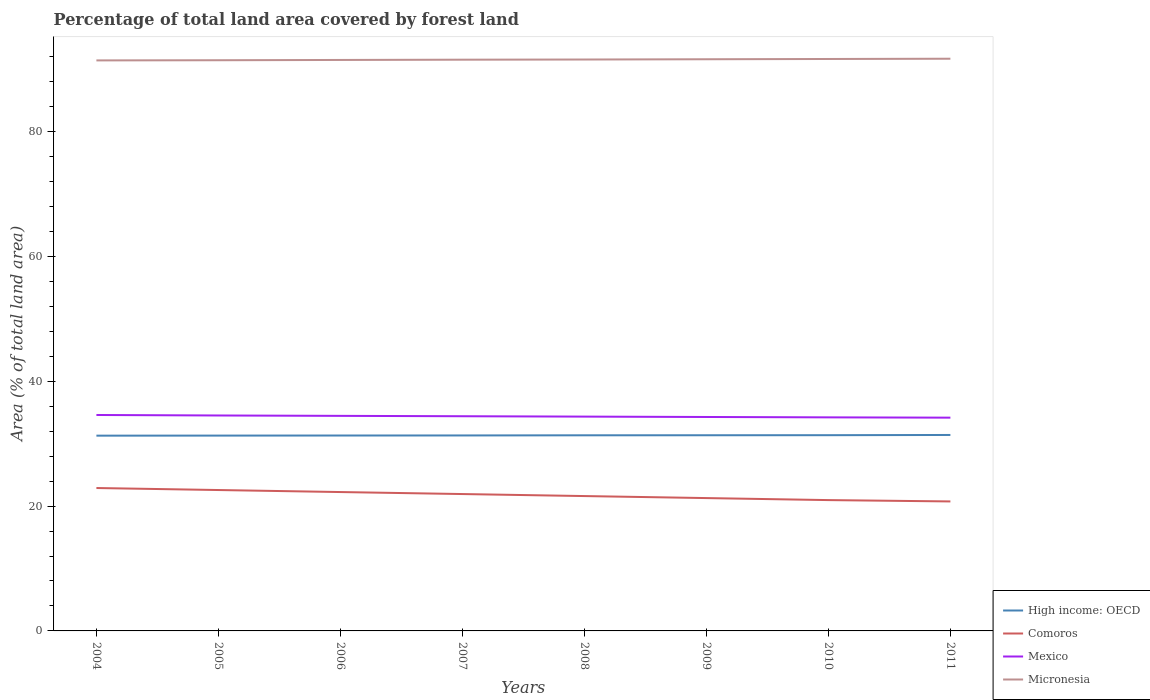How many different coloured lines are there?
Give a very brief answer. 4. Does the line corresponding to Comoros intersect with the line corresponding to Micronesia?
Offer a very short reply. No. Is the number of lines equal to the number of legend labels?
Give a very brief answer. Yes. Across all years, what is the maximum percentage of forest land in High income: OECD?
Offer a very short reply. 31.28. What is the total percentage of forest land in High income: OECD in the graph?
Your answer should be compact. -0.02. What is the difference between the highest and the second highest percentage of forest land in Comoros?
Provide a short and direct response. 2.15. What is the difference between the highest and the lowest percentage of forest land in Comoros?
Make the answer very short. 4. Is the percentage of forest land in Micronesia strictly greater than the percentage of forest land in High income: OECD over the years?
Your answer should be compact. No. How many lines are there?
Keep it short and to the point. 4. Are the values on the major ticks of Y-axis written in scientific E-notation?
Keep it short and to the point. No. Does the graph contain any zero values?
Your answer should be very brief. No. Does the graph contain grids?
Your answer should be compact. No. What is the title of the graph?
Your answer should be compact. Percentage of total land area covered by forest land. What is the label or title of the Y-axis?
Offer a very short reply. Area (% of total land area). What is the Area (% of total land area) of High income: OECD in 2004?
Offer a terse response. 31.28. What is the Area (% of total land area) in Comoros in 2004?
Provide a short and direct response. 22.89. What is the Area (% of total land area) of Mexico in 2004?
Make the answer very short. 34.59. What is the Area (% of total land area) of Micronesia in 2004?
Provide a short and direct response. 91.39. What is the Area (% of total land area) of High income: OECD in 2005?
Offer a very short reply. 31.29. What is the Area (% of total land area) in Comoros in 2005?
Provide a succinct answer. 22.57. What is the Area (% of total land area) of Mexico in 2005?
Offer a very short reply. 34.51. What is the Area (% of total land area) of Micronesia in 2005?
Provide a succinct answer. 91.41. What is the Area (% of total land area) in High income: OECD in 2006?
Keep it short and to the point. 31.3. What is the Area (% of total land area) in Comoros in 2006?
Ensure brevity in your answer.  22.25. What is the Area (% of total land area) in Mexico in 2006?
Offer a terse response. 34.45. What is the Area (% of total land area) in Micronesia in 2006?
Offer a terse response. 91.46. What is the Area (% of total land area) in High income: OECD in 2007?
Keep it short and to the point. 31.31. What is the Area (% of total land area) of Comoros in 2007?
Give a very brief answer. 21.92. What is the Area (% of total land area) in Mexico in 2007?
Offer a very short reply. 34.39. What is the Area (% of total land area) of Micronesia in 2007?
Give a very brief answer. 91.5. What is the Area (% of total land area) in High income: OECD in 2008?
Give a very brief answer. 31.33. What is the Area (% of total land area) in Comoros in 2008?
Offer a terse response. 21.6. What is the Area (% of total land area) of Mexico in 2008?
Offer a terse response. 34.33. What is the Area (% of total land area) in Micronesia in 2008?
Your answer should be compact. 91.53. What is the Area (% of total land area) of High income: OECD in 2009?
Your response must be concise. 31.34. What is the Area (% of total land area) in Comoros in 2009?
Make the answer very short. 21.28. What is the Area (% of total land area) of Mexico in 2009?
Ensure brevity in your answer.  34.27. What is the Area (% of total land area) in Micronesia in 2009?
Your answer should be compact. 91.57. What is the Area (% of total land area) of High income: OECD in 2010?
Make the answer very short. 31.35. What is the Area (% of total land area) of Comoros in 2010?
Provide a succinct answer. 20.96. What is the Area (% of total land area) of Mexico in 2010?
Your response must be concise. 34.21. What is the Area (% of total land area) in Micronesia in 2010?
Offer a very short reply. 91.61. What is the Area (% of total land area) in High income: OECD in 2011?
Ensure brevity in your answer.  31.39. What is the Area (% of total land area) in Comoros in 2011?
Your answer should be very brief. 20.74. What is the Area (% of total land area) of Mexico in 2011?
Make the answer very short. 34.16. What is the Area (% of total land area) in Micronesia in 2011?
Provide a succinct answer. 91.66. Across all years, what is the maximum Area (% of total land area) of High income: OECD?
Provide a short and direct response. 31.39. Across all years, what is the maximum Area (% of total land area) of Comoros?
Provide a short and direct response. 22.89. Across all years, what is the maximum Area (% of total land area) in Mexico?
Offer a terse response. 34.59. Across all years, what is the maximum Area (% of total land area) in Micronesia?
Provide a short and direct response. 91.66. Across all years, what is the minimum Area (% of total land area) in High income: OECD?
Your response must be concise. 31.28. Across all years, what is the minimum Area (% of total land area) of Comoros?
Ensure brevity in your answer.  20.74. Across all years, what is the minimum Area (% of total land area) in Mexico?
Provide a succinct answer. 34.16. Across all years, what is the minimum Area (% of total land area) in Micronesia?
Give a very brief answer. 91.39. What is the total Area (% of total land area) of High income: OECD in the graph?
Your answer should be compact. 250.6. What is the total Area (% of total land area) of Comoros in the graph?
Keep it short and to the point. 174.21. What is the total Area (% of total land area) of Mexico in the graph?
Your answer should be compact. 274.9. What is the total Area (% of total land area) of Micronesia in the graph?
Offer a terse response. 732.13. What is the difference between the Area (% of total land area) in High income: OECD in 2004 and that in 2005?
Ensure brevity in your answer.  -0.01. What is the difference between the Area (% of total land area) in Comoros in 2004 and that in 2005?
Ensure brevity in your answer.  0.32. What is the difference between the Area (% of total land area) of Mexico in 2004 and that in 2005?
Provide a short and direct response. 0.08. What is the difference between the Area (% of total land area) in Micronesia in 2004 and that in 2005?
Provide a succinct answer. -0.03. What is the difference between the Area (% of total land area) in High income: OECD in 2004 and that in 2006?
Your answer should be very brief. -0.02. What is the difference between the Area (% of total land area) of Comoros in 2004 and that in 2006?
Give a very brief answer. 0.64. What is the difference between the Area (% of total land area) in Mexico in 2004 and that in 2006?
Offer a very short reply. 0.14. What is the difference between the Area (% of total land area) in Micronesia in 2004 and that in 2006?
Provide a succinct answer. -0.07. What is the difference between the Area (% of total land area) in High income: OECD in 2004 and that in 2007?
Make the answer very short. -0.03. What is the difference between the Area (% of total land area) of Comoros in 2004 and that in 2007?
Your response must be concise. 0.97. What is the difference between the Area (% of total land area) of Mexico in 2004 and that in 2007?
Your answer should be compact. 0.2. What is the difference between the Area (% of total land area) of Micronesia in 2004 and that in 2007?
Ensure brevity in your answer.  -0.11. What is the difference between the Area (% of total land area) of High income: OECD in 2004 and that in 2008?
Your answer should be very brief. -0.06. What is the difference between the Area (% of total land area) in Comoros in 2004 and that in 2008?
Provide a succinct answer. 1.29. What is the difference between the Area (% of total land area) of Mexico in 2004 and that in 2008?
Offer a very short reply. 0.26. What is the difference between the Area (% of total land area) of Micronesia in 2004 and that in 2008?
Your answer should be very brief. -0.14. What is the difference between the Area (% of total land area) in High income: OECD in 2004 and that in 2009?
Your answer should be very brief. -0.07. What is the difference between the Area (% of total land area) in Comoros in 2004 and that in 2009?
Offer a terse response. 1.61. What is the difference between the Area (% of total land area) of Mexico in 2004 and that in 2009?
Give a very brief answer. 0.32. What is the difference between the Area (% of total land area) of Micronesia in 2004 and that in 2009?
Your response must be concise. -0.19. What is the difference between the Area (% of total land area) in High income: OECD in 2004 and that in 2010?
Offer a terse response. -0.07. What is the difference between the Area (% of total land area) in Comoros in 2004 and that in 2010?
Give a very brief answer. 1.93. What is the difference between the Area (% of total land area) of Mexico in 2004 and that in 2010?
Your response must be concise. 0.38. What is the difference between the Area (% of total land area) of Micronesia in 2004 and that in 2010?
Keep it short and to the point. -0.23. What is the difference between the Area (% of total land area) in High income: OECD in 2004 and that in 2011?
Keep it short and to the point. -0.11. What is the difference between the Area (% of total land area) in Comoros in 2004 and that in 2011?
Provide a succinct answer. 2.15. What is the difference between the Area (% of total land area) in Mexico in 2004 and that in 2011?
Provide a succinct answer. 0.43. What is the difference between the Area (% of total land area) of Micronesia in 2004 and that in 2011?
Provide a succinct answer. -0.27. What is the difference between the Area (% of total land area) in High income: OECD in 2005 and that in 2006?
Your answer should be compact. -0.01. What is the difference between the Area (% of total land area) in Comoros in 2005 and that in 2006?
Offer a terse response. 0.32. What is the difference between the Area (% of total land area) of Mexico in 2005 and that in 2006?
Offer a very short reply. 0.06. What is the difference between the Area (% of total land area) of Micronesia in 2005 and that in 2006?
Your answer should be very brief. -0.04. What is the difference between the Area (% of total land area) of High income: OECD in 2005 and that in 2007?
Make the answer very short. -0.02. What is the difference between the Area (% of total land area) of Comoros in 2005 and that in 2007?
Provide a succinct answer. 0.64. What is the difference between the Area (% of total land area) in Mexico in 2005 and that in 2007?
Make the answer very short. 0.12. What is the difference between the Area (% of total land area) in Micronesia in 2005 and that in 2007?
Your response must be concise. -0.09. What is the difference between the Area (% of total land area) in High income: OECD in 2005 and that in 2008?
Keep it short and to the point. -0.05. What is the difference between the Area (% of total land area) in Comoros in 2005 and that in 2008?
Your answer should be compact. 0.97. What is the difference between the Area (% of total land area) in Mexico in 2005 and that in 2008?
Provide a succinct answer. 0.18. What is the difference between the Area (% of total land area) in Micronesia in 2005 and that in 2008?
Offer a terse response. -0.11. What is the difference between the Area (% of total land area) of High income: OECD in 2005 and that in 2009?
Your response must be concise. -0.06. What is the difference between the Area (% of total land area) in Comoros in 2005 and that in 2009?
Your answer should be compact. 1.29. What is the difference between the Area (% of total land area) in Mexico in 2005 and that in 2009?
Keep it short and to the point. 0.24. What is the difference between the Area (% of total land area) of Micronesia in 2005 and that in 2009?
Give a very brief answer. -0.16. What is the difference between the Area (% of total land area) of High income: OECD in 2005 and that in 2010?
Give a very brief answer. -0.06. What is the difference between the Area (% of total land area) of Comoros in 2005 and that in 2010?
Keep it short and to the point. 1.61. What is the difference between the Area (% of total land area) in Mexico in 2005 and that in 2010?
Your answer should be compact. 0.3. What is the difference between the Area (% of total land area) of Micronesia in 2005 and that in 2010?
Your answer should be very brief. -0.2. What is the difference between the Area (% of total land area) of High income: OECD in 2005 and that in 2011?
Make the answer very short. -0.1. What is the difference between the Area (% of total land area) of Comoros in 2005 and that in 2011?
Your answer should be compact. 1.83. What is the difference between the Area (% of total land area) in Mexico in 2005 and that in 2011?
Your answer should be very brief. 0.35. What is the difference between the Area (% of total land area) in Micronesia in 2005 and that in 2011?
Provide a short and direct response. -0.24. What is the difference between the Area (% of total land area) in High income: OECD in 2006 and that in 2007?
Your response must be concise. -0.01. What is the difference between the Area (% of total land area) in Comoros in 2006 and that in 2007?
Keep it short and to the point. 0.32. What is the difference between the Area (% of total land area) in Mexico in 2006 and that in 2007?
Give a very brief answer. 0.06. What is the difference between the Area (% of total land area) in Micronesia in 2006 and that in 2007?
Provide a succinct answer. -0.04. What is the difference between the Area (% of total land area) of High income: OECD in 2006 and that in 2008?
Offer a terse response. -0.04. What is the difference between the Area (% of total land area) in Comoros in 2006 and that in 2008?
Offer a terse response. 0.64. What is the difference between the Area (% of total land area) of Mexico in 2006 and that in 2008?
Your answer should be compact. 0.12. What is the difference between the Area (% of total land area) in Micronesia in 2006 and that in 2008?
Offer a very short reply. -0.07. What is the difference between the Area (% of total land area) in High income: OECD in 2006 and that in 2009?
Offer a terse response. -0.04. What is the difference between the Area (% of total land area) in Comoros in 2006 and that in 2009?
Make the answer very short. 0.97. What is the difference between the Area (% of total land area) in Mexico in 2006 and that in 2009?
Give a very brief answer. 0.18. What is the difference between the Area (% of total land area) in Micronesia in 2006 and that in 2009?
Ensure brevity in your answer.  -0.11. What is the difference between the Area (% of total land area) in High income: OECD in 2006 and that in 2010?
Give a very brief answer. -0.05. What is the difference between the Area (% of total land area) in Comoros in 2006 and that in 2010?
Provide a short and direct response. 1.29. What is the difference between the Area (% of total land area) of Mexico in 2006 and that in 2010?
Your answer should be very brief. 0.24. What is the difference between the Area (% of total land area) of Micronesia in 2006 and that in 2010?
Your response must be concise. -0.16. What is the difference between the Area (% of total land area) in High income: OECD in 2006 and that in 2011?
Ensure brevity in your answer.  -0.09. What is the difference between the Area (% of total land area) in Comoros in 2006 and that in 2011?
Ensure brevity in your answer.  1.5. What is the difference between the Area (% of total land area) of Mexico in 2006 and that in 2011?
Give a very brief answer. 0.29. What is the difference between the Area (% of total land area) of High income: OECD in 2007 and that in 2008?
Provide a short and direct response. -0.03. What is the difference between the Area (% of total land area) of Comoros in 2007 and that in 2008?
Provide a short and direct response. 0.32. What is the difference between the Area (% of total land area) in Mexico in 2007 and that in 2008?
Give a very brief answer. 0.06. What is the difference between the Area (% of total land area) in Micronesia in 2007 and that in 2008?
Offer a very short reply. -0.03. What is the difference between the Area (% of total land area) in High income: OECD in 2007 and that in 2009?
Make the answer very short. -0.03. What is the difference between the Area (% of total land area) in Comoros in 2007 and that in 2009?
Keep it short and to the point. 0.64. What is the difference between the Area (% of total land area) of Mexico in 2007 and that in 2009?
Ensure brevity in your answer.  0.12. What is the difference between the Area (% of total land area) of Micronesia in 2007 and that in 2009?
Your answer should be compact. -0.07. What is the difference between the Area (% of total land area) in High income: OECD in 2007 and that in 2010?
Your answer should be very brief. -0.04. What is the difference between the Area (% of total land area) in Comoros in 2007 and that in 2010?
Offer a terse response. 0.97. What is the difference between the Area (% of total land area) of Mexico in 2007 and that in 2010?
Your answer should be very brief. 0.18. What is the difference between the Area (% of total land area) of Micronesia in 2007 and that in 2010?
Keep it short and to the point. -0.11. What is the difference between the Area (% of total land area) in High income: OECD in 2007 and that in 2011?
Keep it short and to the point. -0.08. What is the difference between the Area (% of total land area) in Comoros in 2007 and that in 2011?
Make the answer very short. 1.18. What is the difference between the Area (% of total land area) of Mexico in 2007 and that in 2011?
Offer a terse response. 0.23. What is the difference between the Area (% of total land area) of Micronesia in 2007 and that in 2011?
Your answer should be compact. -0.16. What is the difference between the Area (% of total land area) in High income: OECD in 2008 and that in 2009?
Your response must be concise. -0.01. What is the difference between the Area (% of total land area) in Comoros in 2008 and that in 2009?
Offer a very short reply. 0.32. What is the difference between the Area (% of total land area) in Mexico in 2008 and that in 2009?
Your answer should be very brief. 0.06. What is the difference between the Area (% of total land area) of Micronesia in 2008 and that in 2009?
Make the answer very short. -0.04. What is the difference between the Area (% of total land area) in High income: OECD in 2008 and that in 2010?
Ensure brevity in your answer.  -0.02. What is the difference between the Area (% of total land area) of Comoros in 2008 and that in 2010?
Keep it short and to the point. 0.64. What is the difference between the Area (% of total land area) of Mexico in 2008 and that in 2010?
Offer a terse response. 0.12. What is the difference between the Area (% of total land area) of Micronesia in 2008 and that in 2010?
Your answer should be compact. -0.09. What is the difference between the Area (% of total land area) of High income: OECD in 2008 and that in 2011?
Ensure brevity in your answer.  -0.05. What is the difference between the Area (% of total land area) in Comoros in 2008 and that in 2011?
Your answer should be very brief. 0.86. What is the difference between the Area (% of total land area) in Mexico in 2008 and that in 2011?
Offer a terse response. 0.17. What is the difference between the Area (% of total land area) in Micronesia in 2008 and that in 2011?
Your answer should be compact. -0.13. What is the difference between the Area (% of total land area) of High income: OECD in 2009 and that in 2010?
Ensure brevity in your answer.  -0.01. What is the difference between the Area (% of total land area) of Comoros in 2009 and that in 2010?
Give a very brief answer. 0.32. What is the difference between the Area (% of total land area) of Mexico in 2009 and that in 2010?
Keep it short and to the point. 0.06. What is the difference between the Area (% of total land area) in Micronesia in 2009 and that in 2010?
Offer a very short reply. -0.04. What is the difference between the Area (% of total land area) in High income: OECD in 2009 and that in 2011?
Ensure brevity in your answer.  -0.04. What is the difference between the Area (% of total land area) in Comoros in 2009 and that in 2011?
Provide a short and direct response. 0.54. What is the difference between the Area (% of total land area) of Mexico in 2009 and that in 2011?
Ensure brevity in your answer.  0.11. What is the difference between the Area (% of total land area) of Micronesia in 2009 and that in 2011?
Ensure brevity in your answer.  -0.09. What is the difference between the Area (% of total land area) in High income: OECD in 2010 and that in 2011?
Keep it short and to the point. -0.04. What is the difference between the Area (% of total land area) in Comoros in 2010 and that in 2011?
Keep it short and to the point. 0.21. What is the difference between the Area (% of total land area) of Mexico in 2010 and that in 2011?
Your answer should be very brief. 0.05. What is the difference between the Area (% of total land area) in Micronesia in 2010 and that in 2011?
Keep it short and to the point. -0.04. What is the difference between the Area (% of total land area) of High income: OECD in 2004 and the Area (% of total land area) of Comoros in 2005?
Offer a terse response. 8.71. What is the difference between the Area (% of total land area) of High income: OECD in 2004 and the Area (% of total land area) of Mexico in 2005?
Your response must be concise. -3.23. What is the difference between the Area (% of total land area) in High income: OECD in 2004 and the Area (% of total land area) in Micronesia in 2005?
Your answer should be very brief. -60.14. What is the difference between the Area (% of total land area) in Comoros in 2004 and the Area (% of total land area) in Mexico in 2005?
Provide a succinct answer. -11.62. What is the difference between the Area (% of total land area) of Comoros in 2004 and the Area (% of total land area) of Micronesia in 2005?
Your answer should be compact. -68.52. What is the difference between the Area (% of total land area) of Mexico in 2004 and the Area (% of total land area) of Micronesia in 2005?
Provide a short and direct response. -56.83. What is the difference between the Area (% of total land area) of High income: OECD in 2004 and the Area (% of total land area) of Comoros in 2006?
Your answer should be very brief. 9.03. What is the difference between the Area (% of total land area) of High income: OECD in 2004 and the Area (% of total land area) of Mexico in 2006?
Your answer should be compact. -3.17. What is the difference between the Area (% of total land area) of High income: OECD in 2004 and the Area (% of total land area) of Micronesia in 2006?
Give a very brief answer. -60.18. What is the difference between the Area (% of total land area) in Comoros in 2004 and the Area (% of total land area) in Mexico in 2006?
Keep it short and to the point. -11.56. What is the difference between the Area (% of total land area) of Comoros in 2004 and the Area (% of total land area) of Micronesia in 2006?
Give a very brief answer. -68.57. What is the difference between the Area (% of total land area) in Mexico in 2004 and the Area (% of total land area) in Micronesia in 2006?
Provide a short and direct response. -56.87. What is the difference between the Area (% of total land area) of High income: OECD in 2004 and the Area (% of total land area) of Comoros in 2007?
Offer a terse response. 9.35. What is the difference between the Area (% of total land area) of High income: OECD in 2004 and the Area (% of total land area) of Mexico in 2007?
Keep it short and to the point. -3.11. What is the difference between the Area (% of total land area) in High income: OECD in 2004 and the Area (% of total land area) in Micronesia in 2007?
Your answer should be very brief. -60.22. What is the difference between the Area (% of total land area) of Comoros in 2004 and the Area (% of total land area) of Mexico in 2007?
Your answer should be compact. -11.5. What is the difference between the Area (% of total land area) of Comoros in 2004 and the Area (% of total land area) of Micronesia in 2007?
Give a very brief answer. -68.61. What is the difference between the Area (% of total land area) in Mexico in 2004 and the Area (% of total land area) in Micronesia in 2007?
Offer a very short reply. -56.91. What is the difference between the Area (% of total land area) in High income: OECD in 2004 and the Area (% of total land area) in Comoros in 2008?
Ensure brevity in your answer.  9.68. What is the difference between the Area (% of total land area) of High income: OECD in 2004 and the Area (% of total land area) of Mexico in 2008?
Make the answer very short. -3.05. What is the difference between the Area (% of total land area) of High income: OECD in 2004 and the Area (% of total land area) of Micronesia in 2008?
Provide a short and direct response. -60.25. What is the difference between the Area (% of total land area) of Comoros in 2004 and the Area (% of total land area) of Mexico in 2008?
Provide a short and direct response. -11.44. What is the difference between the Area (% of total land area) of Comoros in 2004 and the Area (% of total land area) of Micronesia in 2008?
Your answer should be compact. -68.64. What is the difference between the Area (% of total land area) of Mexico in 2004 and the Area (% of total land area) of Micronesia in 2008?
Your answer should be very brief. -56.94. What is the difference between the Area (% of total land area) of High income: OECD in 2004 and the Area (% of total land area) of Comoros in 2009?
Give a very brief answer. 10. What is the difference between the Area (% of total land area) of High income: OECD in 2004 and the Area (% of total land area) of Mexico in 2009?
Make the answer very short. -2.99. What is the difference between the Area (% of total land area) of High income: OECD in 2004 and the Area (% of total land area) of Micronesia in 2009?
Provide a succinct answer. -60.29. What is the difference between the Area (% of total land area) of Comoros in 2004 and the Area (% of total land area) of Mexico in 2009?
Ensure brevity in your answer.  -11.38. What is the difference between the Area (% of total land area) of Comoros in 2004 and the Area (% of total land area) of Micronesia in 2009?
Ensure brevity in your answer.  -68.68. What is the difference between the Area (% of total land area) in Mexico in 2004 and the Area (% of total land area) in Micronesia in 2009?
Provide a succinct answer. -56.98. What is the difference between the Area (% of total land area) in High income: OECD in 2004 and the Area (% of total land area) in Comoros in 2010?
Your response must be concise. 10.32. What is the difference between the Area (% of total land area) of High income: OECD in 2004 and the Area (% of total land area) of Mexico in 2010?
Your answer should be very brief. -2.93. What is the difference between the Area (% of total land area) in High income: OECD in 2004 and the Area (% of total land area) in Micronesia in 2010?
Make the answer very short. -60.34. What is the difference between the Area (% of total land area) in Comoros in 2004 and the Area (% of total land area) in Mexico in 2010?
Your response must be concise. -11.32. What is the difference between the Area (% of total land area) of Comoros in 2004 and the Area (% of total land area) of Micronesia in 2010?
Give a very brief answer. -68.72. What is the difference between the Area (% of total land area) of Mexico in 2004 and the Area (% of total land area) of Micronesia in 2010?
Your answer should be compact. -57.03. What is the difference between the Area (% of total land area) of High income: OECD in 2004 and the Area (% of total land area) of Comoros in 2011?
Offer a terse response. 10.54. What is the difference between the Area (% of total land area) of High income: OECD in 2004 and the Area (% of total land area) of Mexico in 2011?
Provide a short and direct response. -2.88. What is the difference between the Area (% of total land area) in High income: OECD in 2004 and the Area (% of total land area) in Micronesia in 2011?
Offer a terse response. -60.38. What is the difference between the Area (% of total land area) in Comoros in 2004 and the Area (% of total land area) in Mexico in 2011?
Your response must be concise. -11.27. What is the difference between the Area (% of total land area) of Comoros in 2004 and the Area (% of total land area) of Micronesia in 2011?
Your response must be concise. -68.77. What is the difference between the Area (% of total land area) of Mexico in 2004 and the Area (% of total land area) of Micronesia in 2011?
Provide a short and direct response. -57.07. What is the difference between the Area (% of total land area) of High income: OECD in 2005 and the Area (% of total land area) of Comoros in 2006?
Your answer should be compact. 9.04. What is the difference between the Area (% of total land area) of High income: OECD in 2005 and the Area (% of total land area) of Mexico in 2006?
Offer a very short reply. -3.16. What is the difference between the Area (% of total land area) in High income: OECD in 2005 and the Area (% of total land area) in Micronesia in 2006?
Provide a succinct answer. -60.17. What is the difference between the Area (% of total land area) in Comoros in 2005 and the Area (% of total land area) in Mexico in 2006?
Keep it short and to the point. -11.88. What is the difference between the Area (% of total land area) in Comoros in 2005 and the Area (% of total land area) in Micronesia in 2006?
Make the answer very short. -68.89. What is the difference between the Area (% of total land area) in Mexico in 2005 and the Area (% of total land area) in Micronesia in 2006?
Your response must be concise. -56.95. What is the difference between the Area (% of total land area) in High income: OECD in 2005 and the Area (% of total land area) in Comoros in 2007?
Give a very brief answer. 9.37. What is the difference between the Area (% of total land area) in High income: OECD in 2005 and the Area (% of total land area) in Mexico in 2007?
Your answer should be very brief. -3.1. What is the difference between the Area (% of total land area) of High income: OECD in 2005 and the Area (% of total land area) of Micronesia in 2007?
Offer a terse response. -60.21. What is the difference between the Area (% of total land area) of Comoros in 2005 and the Area (% of total land area) of Mexico in 2007?
Offer a terse response. -11.82. What is the difference between the Area (% of total land area) of Comoros in 2005 and the Area (% of total land area) of Micronesia in 2007?
Keep it short and to the point. -68.93. What is the difference between the Area (% of total land area) in Mexico in 2005 and the Area (% of total land area) in Micronesia in 2007?
Offer a very short reply. -56.99. What is the difference between the Area (% of total land area) in High income: OECD in 2005 and the Area (% of total land area) in Comoros in 2008?
Your answer should be very brief. 9.69. What is the difference between the Area (% of total land area) of High income: OECD in 2005 and the Area (% of total land area) of Mexico in 2008?
Your answer should be compact. -3.04. What is the difference between the Area (% of total land area) in High income: OECD in 2005 and the Area (% of total land area) in Micronesia in 2008?
Keep it short and to the point. -60.24. What is the difference between the Area (% of total land area) of Comoros in 2005 and the Area (% of total land area) of Mexico in 2008?
Offer a very short reply. -11.76. What is the difference between the Area (% of total land area) of Comoros in 2005 and the Area (% of total land area) of Micronesia in 2008?
Offer a very short reply. -68.96. What is the difference between the Area (% of total land area) of Mexico in 2005 and the Area (% of total land area) of Micronesia in 2008?
Your answer should be compact. -57.02. What is the difference between the Area (% of total land area) of High income: OECD in 2005 and the Area (% of total land area) of Comoros in 2009?
Your answer should be compact. 10.01. What is the difference between the Area (% of total land area) in High income: OECD in 2005 and the Area (% of total land area) in Mexico in 2009?
Make the answer very short. -2.98. What is the difference between the Area (% of total land area) of High income: OECD in 2005 and the Area (% of total land area) of Micronesia in 2009?
Your response must be concise. -60.28. What is the difference between the Area (% of total land area) of Comoros in 2005 and the Area (% of total land area) of Mexico in 2009?
Offer a very short reply. -11.7. What is the difference between the Area (% of total land area) in Comoros in 2005 and the Area (% of total land area) in Micronesia in 2009?
Your response must be concise. -69. What is the difference between the Area (% of total land area) of Mexico in 2005 and the Area (% of total land area) of Micronesia in 2009?
Your response must be concise. -57.06. What is the difference between the Area (% of total land area) in High income: OECD in 2005 and the Area (% of total land area) in Comoros in 2010?
Your response must be concise. 10.33. What is the difference between the Area (% of total land area) of High income: OECD in 2005 and the Area (% of total land area) of Mexico in 2010?
Give a very brief answer. -2.92. What is the difference between the Area (% of total land area) of High income: OECD in 2005 and the Area (% of total land area) of Micronesia in 2010?
Your answer should be compact. -60.33. What is the difference between the Area (% of total land area) of Comoros in 2005 and the Area (% of total land area) of Mexico in 2010?
Your answer should be compact. -11.64. What is the difference between the Area (% of total land area) of Comoros in 2005 and the Area (% of total land area) of Micronesia in 2010?
Your response must be concise. -69.05. What is the difference between the Area (% of total land area) in Mexico in 2005 and the Area (% of total land area) in Micronesia in 2010?
Ensure brevity in your answer.  -57.11. What is the difference between the Area (% of total land area) of High income: OECD in 2005 and the Area (% of total land area) of Comoros in 2011?
Provide a short and direct response. 10.55. What is the difference between the Area (% of total land area) in High income: OECD in 2005 and the Area (% of total land area) in Mexico in 2011?
Keep it short and to the point. -2.87. What is the difference between the Area (% of total land area) of High income: OECD in 2005 and the Area (% of total land area) of Micronesia in 2011?
Your response must be concise. -60.37. What is the difference between the Area (% of total land area) in Comoros in 2005 and the Area (% of total land area) in Mexico in 2011?
Your answer should be very brief. -11.59. What is the difference between the Area (% of total land area) in Comoros in 2005 and the Area (% of total land area) in Micronesia in 2011?
Provide a short and direct response. -69.09. What is the difference between the Area (% of total land area) in Mexico in 2005 and the Area (% of total land area) in Micronesia in 2011?
Provide a succinct answer. -57.15. What is the difference between the Area (% of total land area) of High income: OECD in 2006 and the Area (% of total land area) of Comoros in 2007?
Provide a short and direct response. 9.38. What is the difference between the Area (% of total land area) in High income: OECD in 2006 and the Area (% of total land area) in Mexico in 2007?
Offer a terse response. -3.09. What is the difference between the Area (% of total land area) of High income: OECD in 2006 and the Area (% of total land area) of Micronesia in 2007?
Your response must be concise. -60.2. What is the difference between the Area (% of total land area) of Comoros in 2006 and the Area (% of total land area) of Mexico in 2007?
Ensure brevity in your answer.  -12.14. What is the difference between the Area (% of total land area) of Comoros in 2006 and the Area (% of total land area) of Micronesia in 2007?
Offer a terse response. -69.25. What is the difference between the Area (% of total land area) of Mexico in 2006 and the Area (% of total land area) of Micronesia in 2007?
Make the answer very short. -57.05. What is the difference between the Area (% of total land area) in High income: OECD in 2006 and the Area (% of total land area) in Comoros in 2008?
Provide a succinct answer. 9.7. What is the difference between the Area (% of total land area) in High income: OECD in 2006 and the Area (% of total land area) in Mexico in 2008?
Provide a short and direct response. -3.03. What is the difference between the Area (% of total land area) of High income: OECD in 2006 and the Area (% of total land area) of Micronesia in 2008?
Offer a terse response. -60.23. What is the difference between the Area (% of total land area) of Comoros in 2006 and the Area (% of total land area) of Mexico in 2008?
Offer a very short reply. -12.08. What is the difference between the Area (% of total land area) in Comoros in 2006 and the Area (% of total land area) in Micronesia in 2008?
Offer a very short reply. -69.28. What is the difference between the Area (% of total land area) in Mexico in 2006 and the Area (% of total land area) in Micronesia in 2008?
Provide a succinct answer. -57.08. What is the difference between the Area (% of total land area) in High income: OECD in 2006 and the Area (% of total land area) in Comoros in 2009?
Provide a short and direct response. 10.02. What is the difference between the Area (% of total land area) in High income: OECD in 2006 and the Area (% of total land area) in Mexico in 2009?
Ensure brevity in your answer.  -2.97. What is the difference between the Area (% of total land area) in High income: OECD in 2006 and the Area (% of total land area) in Micronesia in 2009?
Offer a terse response. -60.27. What is the difference between the Area (% of total land area) in Comoros in 2006 and the Area (% of total land area) in Mexico in 2009?
Provide a succinct answer. -12.02. What is the difference between the Area (% of total land area) of Comoros in 2006 and the Area (% of total land area) of Micronesia in 2009?
Your answer should be compact. -69.33. What is the difference between the Area (% of total land area) of Mexico in 2006 and the Area (% of total land area) of Micronesia in 2009?
Provide a short and direct response. -57.12. What is the difference between the Area (% of total land area) in High income: OECD in 2006 and the Area (% of total land area) in Comoros in 2010?
Provide a short and direct response. 10.34. What is the difference between the Area (% of total land area) in High income: OECD in 2006 and the Area (% of total land area) in Mexico in 2010?
Provide a succinct answer. -2.91. What is the difference between the Area (% of total land area) of High income: OECD in 2006 and the Area (% of total land area) of Micronesia in 2010?
Offer a very short reply. -60.31. What is the difference between the Area (% of total land area) of Comoros in 2006 and the Area (% of total land area) of Mexico in 2010?
Ensure brevity in your answer.  -11.96. What is the difference between the Area (% of total land area) of Comoros in 2006 and the Area (% of total land area) of Micronesia in 2010?
Your answer should be very brief. -69.37. What is the difference between the Area (% of total land area) in Mexico in 2006 and the Area (% of total land area) in Micronesia in 2010?
Your answer should be very brief. -57.17. What is the difference between the Area (% of total land area) in High income: OECD in 2006 and the Area (% of total land area) in Comoros in 2011?
Offer a terse response. 10.56. What is the difference between the Area (% of total land area) in High income: OECD in 2006 and the Area (% of total land area) in Mexico in 2011?
Offer a very short reply. -2.86. What is the difference between the Area (% of total land area) in High income: OECD in 2006 and the Area (% of total land area) in Micronesia in 2011?
Offer a very short reply. -60.36. What is the difference between the Area (% of total land area) of Comoros in 2006 and the Area (% of total land area) of Mexico in 2011?
Your response must be concise. -11.91. What is the difference between the Area (% of total land area) of Comoros in 2006 and the Area (% of total land area) of Micronesia in 2011?
Offer a terse response. -69.41. What is the difference between the Area (% of total land area) of Mexico in 2006 and the Area (% of total land area) of Micronesia in 2011?
Provide a succinct answer. -57.21. What is the difference between the Area (% of total land area) in High income: OECD in 2007 and the Area (% of total land area) in Comoros in 2008?
Keep it short and to the point. 9.71. What is the difference between the Area (% of total land area) of High income: OECD in 2007 and the Area (% of total land area) of Mexico in 2008?
Provide a succinct answer. -3.02. What is the difference between the Area (% of total land area) of High income: OECD in 2007 and the Area (% of total land area) of Micronesia in 2008?
Provide a succinct answer. -60.22. What is the difference between the Area (% of total land area) of Comoros in 2007 and the Area (% of total land area) of Mexico in 2008?
Keep it short and to the point. -12.4. What is the difference between the Area (% of total land area) of Comoros in 2007 and the Area (% of total land area) of Micronesia in 2008?
Offer a very short reply. -69.6. What is the difference between the Area (% of total land area) in Mexico in 2007 and the Area (% of total land area) in Micronesia in 2008?
Provide a succinct answer. -57.14. What is the difference between the Area (% of total land area) of High income: OECD in 2007 and the Area (% of total land area) of Comoros in 2009?
Provide a succinct answer. 10.03. What is the difference between the Area (% of total land area) of High income: OECD in 2007 and the Area (% of total land area) of Mexico in 2009?
Offer a very short reply. -2.96. What is the difference between the Area (% of total land area) of High income: OECD in 2007 and the Area (% of total land area) of Micronesia in 2009?
Offer a very short reply. -60.26. What is the difference between the Area (% of total land area) in Comoros in 2007 and the Area (% of total land area) in Mexico in 2009?
Your answer should be compact. -12.34. What is the difference between the Area (% of total land area) in Comoros in 2007 and the Area (% of total land area) in Micronesia in 2009?
Your answer should be very brief. -69.65. What is the difference between the Area (% of total land area) of Mexico in 2007 and the Area (% of total land area) of Micronesia in 2009?
Ensure brevity in your answer.  -57.18. What is the difference between the Area (% of total land area) of High income: OECD in 2007 and the Area (% of total land area) of Comoros in 2010?
Provide a succinct answer. 10.35. What is the difference between the Area (% of total land area) in High income: OECD in 2007 and the Area (% of total land area) in Mexico in 2010?
Your response must be concise. -2.9. What is the difference between the Area (% of total land area) in High income: OECD in 2007 and the Area (% of total land area) in Micronesia in 2010?
Make the answer very short. -60.3. What is the difference between the Area (% of total land area) of Comoros in 2007 and the Area (% of total land area) of Mexico in 2010?
Offer a terse response. -12.28. What is the difference between the Area (% of total land area) in Comoros in 2007 and the Area (% of total land area) in Micronesia in 2010?
Offer a very short reply. -69.69. What is the difference between the Area (% of total land area) of Mexico in 2007 and the Area (% of total land area) of Micronesia in 2010?
Your answer should be compact. -57.23. What is the difference between the Area (% of total land area) in High income: OECD in 2007 and the Area (% of total land area) in Comoros in 2011?
Make the answer very short. 10.57. What is the difference between the Area (% of total land area) in High income: OECD in 2007 and the Area (% of total land area) in Mexico in 2011?
Keep it short and to the point. -2.85. What is the difference between the Area (% of total land area) of High income: OECD in 2007 and the Area (% of total land area) of Micronesia in 2011?
Keep it short and to the point. -60.35. What is the difference between the Area (% of total land area) of Comoros in 2007 and the Area (% of total land area) of Mexico in 2011?
Offer a very short reply. -12.24. What is the difference between the Area (% of total land area) of Comoros in 2007 and the Area (% of total land area) of Micronesia in 2011?
Provide a succinct answer. -69.73. What is the difference between the Area (% of total land area) in Mexico in 2007 and the Area (% of total land area) in Micronesia in 2011?
Ensure brevity in your answer.  -57.27. What is the difference between the Area (% of total land area) in High income: OECD in 2008 and the Area (% of total land area) in Comoros in 2009?
Make the answer very short. 10.06. What is the difference between the Area (% of total land area) in High income: OECD in 2008 and the Area (% of total land area) in Mexico in 2009?
Provide a short and direct response. -2.93. What is the difference between the Area (% of total land area) in High income: OECD in 2008 and the Area (% of total land area) in Micronesia in 2009?
Make the answer very short. -60.24. What is the difference between the Area (% of total land area) in Comoros in 2008 and the Area (% of total land area) in Mexico in 2009?
Your answer should be very brief. -12.67. What is the difference between the Area (% of total land area) of Comoros in 2008 and the Area (% of total land area) of Micronesia in 2009?
Make the answer very short. -69.97. What is the difference between the Area (% of total land area) of Mexico in 2008 and the Area (% of total land area) of Micronesia in 2009?
Keep it short and to the point. -57.24. What is the difference between the Area (% of total land area) of High income: OECD in 2008 and the Area (% of total land area) of Comoros in 2010?
Your answer should be very brief. 10.38. What is the difference between the Area (% of total land area) of High income: OECD in 2008 and the Area (% of total land area) of Mexico in 2010?
Offer a very short reply. -2.87. What is the difference between the Area (% of total land area) in High income: OECD in 2008 and the Area (% of total land area) in Micronesia in 2010?
Make the answer very short. -60.28. What is the difference between the Area (% of total land area) of Comoros in 2008 and the Area (% of total land area) of Mexico in 2010?
Your answer should be very brief. -12.61. What is the difference between the Area (% of total land area) of Comoros in 2008 and the Area (% of total land area) of Micronesia in 2010?
Provide a short and direct response. -70.01. What is the difference between the Area (% of total land area) in Mexico in 2008 and the Area (% of total land area) in Micronesia in 2010?
Your answer should be compact. -57.29. What is the difference between the Area (% of total land area) in High income: OECD in 2008 and the Area (% of total land area) in Comoros in 2011?
Your answer should be very brief. 10.59. What is the difference between the Area (% of total land area) in High income: OECD in 2008 and the Area (% of total land area) in Mexico in 2011?
Offer a very short reply. -2.83. What is the difference between the Area (% of total land area) of High income: OECD in 2008 and the Area (% of total land area) of Micronesia in 2011?
Your answer should be compact. -60.32. What is the difference between the Area (% of total land area) in Comoros in 2008 and the Area (% of total land area) in Mexico in 2011?
Provide a short and direct response. -12.56. What is the difference between the Area (% of total land area) of Comoros in 2008 and the Area (% of total land area) of Micronesia in 2011?
Offer a terse response. -70.06. What is the difference between the Area (% of total land area) in Mexico in 2008 and the Area (% of total land area) in Micronesia in 2011?
Make the answer very short. -57.33. What is the difference between the Area (% of total land area) in High income: OECD in 2009 and the Area (% of total land area) in Comoros in 2010?
Keep it short and to the point. 10.39. What is the difference between the Area (% of total land area) of High income: OECD in 2009 and the Area (% of total land area) of Mexico in 2010?
Your response must be concise. -2.86. What is the difference between the Area (% of total land area) of High income: OECD in 2009 and the Area (% of total land area) of Micronesia in 2010?
Make the answer very short. -60.27. What is the difference between the Area (% of total land area) of Comoros in 2009 and the Area (% of total land area) of Mexico in 2010?
Keep it short and to the point. -12.93. What is the difference between the Area (% of total land area) of Comoros in 2009 and the Area (% of total land area) of Micronesia in 2010?
Offer a terse response. -70.34. What is the difference between the Area (% of total land area) of Mexico in 2009 and the Area (% of total land area) of Micronesia in 2010?
Provide a short and direct response. -57.35. What is the difference between the Area (% of total land area) of High income: OECD in 2009 and the Area (% of total land area) of Comoros in 2011?
Your answer should be compact. 10.6. What is the difference between the Area (% of total land area) of High income: OECD in 2009 and the Area (% of total land area) of Mexico in 2011?
Your answer should be compact. -2.82. What is the difference between the Area (% of total land area) in High income: OECD in 2009 and the Area (% of total land area) in Micronesia in 2011?
Keep it short and to the point. -60.31. What is the difference between the Area (% of total land area) in Comoros in 2009 and the Area (% of total land area) in Mexico in 2011?
Your answer should be very brief. -12.88. What is the difference between the Area (% of total land area) in Comoros in 2009 and the Area (% of total land area) in Micronesia in 2011?
Give a very brief answer. -70.38. What is the difference between the Area (% of total land area) of Mexico in 2009 and the Area (% of total land area) of Micronesia in 2011?
Your answer should be compact. -57.39. What is the difference between the Area (% of total land area) in High income: OECD in 2010 and the Area (% of total land area) in Comoros in 2011?
Keep it short and to the point. 10.61. What is the difference between the Area (% of total land area) in High income: OECD in 2010 and the Area (% of total land area) in Mexico in 2011?
Offer a very short reply. -2.81. What is the difference between the Area (% of total land area) in High income: OECD in 2010 and the Area (% of total land area) in Micronesia in 2011?
Your answer should be very brief. -60.3. What is the difference between the Area (% of total land area) of Comoros in 2010 and the Area (% of total land area) of Mexico in 2011?
Provide a succinct answer. -13.2. What is the difference between the Area (% of total land area) of Comoros in 2010 and the Area (% of total land area) of Micronesia in 2011?
Your answer should be compact. -70.7. What is the difference between the Area (% of total land area) in Mexico in 2010 and the Area (% of total land area) in Micronesia in 2011?
Keep it short and to the point. -57.45. What is the average Area (% of total land area) of High income: OECD per year?
Your response must be concise. 31.32. What is the average Area (% of total land area) of Comoros per year?
Make the answer very short. 21.78. What is the average Area (% of total land area) in Mexico per year?
Offer a terse response. 34.36. What is the average Area (% of total land area) of Micronesia per year?
Offer a terse response. 91.52. In the year 2004, what is the difference between the Area (% of total land area) in High income: OECD and Area (% of total land area) in Comoros?
Keep it short and to the point. 8.39. In the year 2004, what is the difference between the Area (% of total land area) in High income: OECD and Area (% of total land area) in Mexico?
Keep it short and to the point. -3.31. In the year 2004, what is the difference between the Area (% of total land area) of High income: OECD and Area (% of total land area) of Micronesia?
Provide a short and direct response. -60.11. In the year 2004, what is the difference between the Area (% of total land area) of Comoros and Area (% of total land area) of Mexico?
Your response must be concise. -11.7. In the year 2004, what is the difference between the Area (% of total land area) in Comoros and Area (% of total land area) in Micronesia?
Make the answer very short. -68.49. In the year 2004, what is the difference between the Area (% of total land area) in Mexico and Area (% of total land area) in Micronesia?
Offer a terse response. -56.8. In the year 2005, what is the difference between the Area (% of total land area) of High income: OECD and Area (% of total land area) of Comoros?
Provide a succinct answer. 8.72. In the year 2005, what is the difference between the Area (% of total land area) of High income: OECD and Area (% of total land area) of Mexico?
Make the answer very short. -3.22. In the year 2005, what is the difference between the Area (% of total land area) in High income: OECD and Area (% of total land area) in Micronesia?
Keep it short and to the point. -60.13. In the year 2005, what is the difference between the Area (% of total land area) in Comoros and Area (% of total land area) in Mexico?
Offer a terse response. -11.94. In the year 2005, what is the difference between the Area (% of total land area) in Comoros and Area (% of total land area) in Micronesia?
Offer a terse response. -68.85. In the year 2005, what is the difference between the Area (% of total land area) in Mexico and Area (% of total land area) in Micronesia?
Ensure brevity in your answer.  -56.91. In the year 2006, what is the difference between the Area (% of total land area) of High income: OECD and Area (% of total land area) of Comoros?
Provide a short and direct response. 9.05. In the year 2006, what is the difference between the Area (% of total land area) in High income: OECD and Area (% of total land area) in Mexico?
Ensure brevity in your answer.  -3.15. In the year 2006, what is the difference between the Area (% of total land area) of High income: OECD and Area (% of total land area) of Micronesia?
Provide a succinct answer. -60.16. In the year 2006, what is the difference between the Area (% of total land area) of Comoros and Area (% of total land area) of Mexico?
Your answer should be very brief. -12.2. In the year 2006, what is the difference between the Area (% of total land area) in Comoros and Area (% of total land area) in Micronesia?
Keep it short and to the point. -69.21. In the year 2006, what is the difference between the Area (% of total land area) of Mexico and Area (% of total land area) of Micronesia?
Your answer should be compact. -57.01. In the year 2007, what is the difference between the Area (% of total land area) in High income: OECD and Area (% of total land area) in Comoros?
Your answer should be compact. 9.39. In the year 2007, what is the difference between the Area (% of total land area) of High income: OECD and Area (% of total land area) of Mexico?
Keep it short and to the point. -3.08. In the year 2007, what is the difference between the Area (% of total land area) of High income: OECD and Area (% of total land area) of Micronesia?
Offer a very short reply. -60.19. In the year 2007, what is the difference between the Area (% of total land area) in Comoros and Area (% of total land area) in Mexico?
Make the answer very short. -12.46. In the year 2007, what is the difference between the Area (% of total land area) of Comoros and Area (% of total land area) of Micronesia?
Your response must be concise. -69.58. In the year 2007, what is the difference between the Area (% of total land area) of Mexico and Area (% of total land area) of Micronesia?
Your answer should be very brief. -57.11. In the year 2008, what is the difference between the Area (% of total land area) in High income: OECD and Area (% of total land area) in Comoros?
Offer a terse response. 9.73. In the year 2008, what is the difference between the Area (% of total land area) of High income: OECD and Area (% of total land area) of Mexico?
Your response must be concise. -2.99. In the year 2008, what is the difference between the Area (% of total land area) in High income: OECD and Area (% of total land area) in Micronesia?
Your answer should be very brief. -60.19. In the year 2008, what is the difference between the Area (% of total land area) of Comoros and Area (% of total land area) of Mexico?
Your response must be concise. -12.73. In the year 2008, what is the difference between the Area (% of total land area) in Comoros and Area (% of total land area) in Micronesia?
Ensure brevity in your answer.  -69.93. In the year 2008, what is the difference between the Area (% of total land area) in Mexico and Area (% of total land area) in Micronesia?
Provide a short and direct response. -57.2. In the year 2009, what is the difference between the Area (% of total land area) in High income: OECD and Area (% of total land area) in Comoros?
Offer a very short reply. 10.06. In the year 2009, what is the difference between the Area (% of total land area) in High income: OECD and Area (% of total land area) in Mexico?
Provide a short and direct response. -2.92. In the year 2009, what is the difference between the Area (% of total land area) of High income: OECD and Area (% of total land area) of Micronesia?
Provide a short and direct response. -60.23. In the year 2009, what is the difference between the Area (% of total land area) in Comoros and Area (% of total land area) in Mexico?
Your answer should be compact. -12.99. In the year 2009, what is the difference between the Area (% of total land area) of Comoros and Area (% of total land area) of Micronesia?
Your answer should be very brief. -70.29. In the year 2009, what is the difference between the Area (% of total land area) in Mexico and Area (% of total land area) in Micronesia?
Your answer should be compact. -57.3. In the year 2010, what is the difference between the Area (% of total land area) of High income: OECD and Area (% of total land area) of Comoros?
Make the answer very short. 10.4. In the year 2010, what is the difference between the Area (% of total land area) of High income: OECD and Area (% of total land area) of Mexico?
Make the answer very short. -2.85. In the year 2010, what is the difference between the Area (% of total land area) in High income: OECD and Area (% of total land area) in Micronesia?
Offer a very short reply. -60.26. In the year 2010, what is the difference between the Area (% of total land area) of Comoros and Area (% of total land area) of Mexico?
Your answer should be very brief. -13.25. In the year 2010, what is the difference between the Area (% of total land area) of Comoros and Area (% of total land area) of Micronesia?
Your response must be concise. -70.66. In the year 2010, what is the difference between the Area (% of total land area) in Mexico and Area (% of total land area) in Micronesia?
Offer a very short reply. -57.41. In the year 2011, what is the difference between the Area (% of total land area) in High income: OECD and Area (% of total land area) in Comoros?
Provide a short and direct response. 10.65. In the year 2011, what is the difference between the Area (% of total land area) in High income: OECD and Area (% of total land area) in Mexico?
Your answer should be very brief. -2.77. In the year 2011, what is the difference between the Area (% of total land area) in High income: OECD and Area (% of total land area) in Micronesia?
Keep it short and to the point. -60.27. In the year 2011, what is the difference between the Area (% of total land area) in Comoros and Area (% of total land area) in Mexico?
Provide a short and direct response. -13.42. In the year 2011, what is the difference between the Area (% of total land area) in Comoros and Area (% of total land area) in Micronesia?
Ensure brevity in your answer.  -70.92. In the year 2011, what is the difference between the Area (% of total land area) in Mexico and Area (% of total land area) in Micronesia?
Offer a very short reply. -57.5. What is the ratio of the Area (% of total land area) in High income: OECD in 2004 to that in 2005?
Give a very brief answer. 1. What is the ratio of the Area (% of total land area) in Comoros in 2004 to that in 2005?
Make the answer very short. 1.01. What is the ratio of the Area (% of total land area) of Mexico in 2004 to that in 2005?
Ensure brevity in your answer.  1. What is the ratio of the Area (% of total land area) in Comoros in 2004 to that in 2006?
Ensure brevity in your answer.  1.03. What is the ratio of the Area (% of total land area) in Micronesia in 2004 to that in 2006?
Give a very brief answer. 1. What is the ratio of the Area (% of total land area) in High income: OECD in 2004 to that in 2007?
Provide a succinct answer. 1. What is the ratio of the Area (% of total land area) of Comoros in 2004 to that in 2007?
Provide a short and direct response. 1.04. What is the ratio of the Area (% of total land area) in Mexico in 2004 to that in 2007?
Your response must be concise. 1.01. What is the ratio of the Area (% of total land area) of Micronesia in 2004 to that in 2007?
Provide a short and direct response. 1. What is the ratio of the Area (% of total land area) in Comoros in 2004 to that in 2008?
Offer a terse response. 1.06. What is the ratio of the Area (% of total land area) of Mexico in 2004 to that in 2008?
Offer a very short reply. 1.01. What is the ratio of the Area (% of total land area) in High income: OECD in 2004 to that in 2009?
Your answer should be very brief. 1. What is the ratio of the Area (% of total land area) in Comoros in 2004 to that in 2009?
Give a very brief answer. 1.08. What is the ratio of the Area (% of total land area) in Mexico in 2004 to that in 2009?
Offer a very short reply. 1.01. What is the ratio of the Area (% of total land area) of Micronesia in 2004 to that in 2009?
Your response must be concise. 1. What is the ratio of the Area (% of total land area) of Comoros in 2004 to that in 2010?
Ensure brevity in your answer.  1.09. What is the ratio of the Area (% of total land area) of Mexico in 2004 to that in 2010?
Provide a short and direct response. 1.01. What is the ratio of the Area (% of total land area) of Comoros in 2004 to that in 2011?
Give a very brief answer. 1.1. What is the ratio of the Area (% of total land area) of Mexico in 2004 to that in 2011?
Keep it short and to the point. 1.01. What is the ratio of the Area (% of total land area) of Micronesia in 2004 to that in 2011?
Your response must be concise. 1. What is the ratio of the Area (% of total land area) in High income: OECD in 2005 to that in 2006?
Your answer should be compact. 1. What is the ratio of the Area (% of total land area) of Comoros in 2005 to that in 2006?
Your answer should be very brief. 1.01. What is the ratio of the Area (% of total land area) in Mexico in 2005 to that in 2006?
Make the answer very short. 1. What is the ratio of the Area (% of total land area) of Micronesia in 2005 to that in 2006?
Your answer should be compact. 1. What is the ratio of the Area (% of total land area) in Comoros in 2005 to that in 2007?
Make the answer very short. 1.03. What is the ratio of the Area (% of total land area) of Mexico in 2005 to that in 2007?
Provide a short and direct response. 1. What is the ratio of the Area (% of total land area) of Comoros in 2005 to that in 2008?
Provide a short and direct response. 1.04. What is the ratio of the Area (% of total land area) in Mexico in 2005 to that in 2008?
Your response must be concise. 1.01. What is the ratio of the Area (% of total land area) of High income: OECD in 2005 to that in 2009?
Offer a terse response. 1. What is the ratio of the Area (% of total land area) of Comoros in 2005 to that in 2009?
Your answer should be very brief. 1.06. What is the ratio of the Area (% of total land area) of Mexico in 2005 to that in 2009?
Provide a succinct answer. 1.01. What is the ratio of the Area (% of total land area) in Mexico in 2005 to that in 2010?
Your response must be concise. 1.01. What is the ratio of the Area (% of total land area) in Micronesia in 2005 to that in 2010?
Keep it short and to the point. 1. What is the ratio of the Area (% of total land area) of Comoros in 2005 to that in 2011?
Offer a terse response. 1.09. What is the ratio of the Area (% of total land area) in Mexico in 2005 to that in 2011?
Offer a very short reply. 1.01. What is the ratio of the Area (% of total land area) of Micronesia in 2005 to that in 2011?
Offer a terse response. 1. What is the ratio of the Area (% of total land area) of Comoros in 2006 to that in 2007?
Provide a short and direct response. 1.01. What is the ratio of the Area (% of total land area) of Mexico in 2006 to that in 2007?
Offer a very short reply. 1. What is the ratio of the Area (% of total land area) of Micronesia in 2006 to that in 2007?
Provide a short and direct response. 1. What is the ratio of the Area (% of total land area) of High income: OECD in 2006 to that in 2008?
Give a very brief answer. 1. What is the ratio of the Area (% of total land area) in Comoros in 2006 to that in 2008?
Offer a very short reply. 1.03. What is the ratio of the Area (% of total land area) in Micronesia in 2006 to that in 2008?
Ensure brevity in your answer.  1. What is the ratio of the Area (% of total land area) of Comoros in 2006 to that in 2009?
Keep it short and to the point. 1.05. What is the ratio of the Area (% of total land area) in Mexico in 2006 to that in 2009?
Offer a terse response. 1.01. What is the ratio of the Area (% of total land area) of High income: OECD in 2006 to that in 2010?
Provide a succinct answer. 1. What is the ratio of the Area (% of total land area) of Comoros in 2006 to that in 2010?
Your response must be concise. 1.06. What is the ratio of the Area (% of total land area) in Mexico in 2006 to that in 2010?
Give a very brief answer. 1.01. What is the ratio of the Area (% of total land area) in Micronesia in 2006 to that in 2010?
Your response must be concise. 1. What is the ratio of the Area (% of total land area) of Comoros in 2006 to that in 2011?
Offer a terse response. 1.07. What is the ratio of the Area (% of total land area) in Mexico in 2006 to that in 2011?
Offer a terse response. 1.01. What is the ratio of the Area (% of total land area) in Comoros in 2007 to that in 2008?
Make the answer very short. 1.01. What is the ratio of the Area (% of total land area) in Comoros in 2007 to that in 2009?
Offer a very short reply. 1.03. What is the ratio of the Area (% of total land area) of Mexico in 2007 to that in 2009?
Offer a terse response. 1. What is the ratio of the Area (% of total land area) in High income: OECD in 2007 to that in 2010?
Keep it short and to the point. 1. What is the ratio of the Area (% of total land area) of Comoros in 2007 to that in 2010?
Offer a very short reply. 1.05. What is the ratio of the Area (% of total land area) of Mexico in 2007 to that in 2010?
Make the answer very short. 1.01. What is the ratio of the Area (% of total land area) of Comoros in 2007 to that in 2011?
Keep it short and to the point. 1.06. What is the ratio of the Area (% of total land area) of Mexico in 2007 to that in 2011?
Your answer should be compact. 1.01. What is the ratio of the Area (% of total land area) of Micronesia in 2007 to that in 2011?
Provide a succinct answer. 1. What is the ratio of the Area (% of total land area) in High income: OECD in 2008 to that in 2009?
Your response must be concise. 1. What is the ratio of the Area (% of total land area) of Comoros in 2008 to that in 2009?
Make the answer very short. 1.02. What is the ratio of the Area (% of total land area) of Mexico in 2008 to that in 2009?
Keep it short and to the point. 1. What is the ratio of the Area (% of total land area) in High income: OECD in 2008 to that in 2010?
Keep it short and to the point. 1. What is the ratio of the Area (% of total land area) in Comoros in 2008 to that in 2010?
Give a very brief answer. 1.03. What is the ratio of the Area (% of total land area) of Mexico in 2008 to that in 2010?
Your answer should be compact. 1. What is the ratio of the Area (% of total land area) in Comoros in 2008 to that in 2011?
Make the answer very short. 1.04. What is the ratio of the Area (% of total land area) in Mexico in 2008 to that in 2011?
Keep it short and to the point. 1. What is the ratio of the Area (% of total land area) of Comoros in 2009 to that in 2010?
Offer a terse response. 1.02. What is the ratio of the Area (% of total land area) in Mexico in 2009 to that in 2010?
Provide a short and direct response. 1. What is the ratio of the Area (% of total land area) in Comoros in 2009 to that in 2011?
Keep it short and to the point. 1.03. What is the ratio of the Area (% of total land area) in Comoros in 2010 to that in 2011?
Provide a short and direct response. 1.01. What is the ratio of the Area (% of total land area) in Mexico in 2010 to that in 2011?
Keep it short and to the point. 1. What is the ratio of the Area (% of total land area) in Micronesia in 2010 to that in 2011?
Offer a very short reply. 1. What is the difference between the highest and the second highest Area (% of total land area) in High income: OECD?
Your response must be concise. 0.04. What is the difference between the highest and the second highest Area (% of total land area) of Comoros?
Make the answer very short. 0.32. What is the difference between the highest and the second highest Area (% of total land area) of Mexico?
Offer a terse response. 0.08. What is the difference between the highest and the second highest Area (% of total land area) of Micronesia?
Keep it short and to the point. 0.04. What is the difference between the highest and the lowest Area (% of total land area) of High income: OECD?
Ensure brevity in your answer.  0.11. What is the difference between the highest and the lowest Area (% of total land area) in Comoros?
Keep it short and to the point. 2.15. What is the difference between the highest and the lowest Area (% of total land area) in Mexico?
Give a very brief answer. 0.43. What is the difference between the highest and the lowest Area (% of total land area) of Micronesia?
Offer a very short reply. 0.27. 